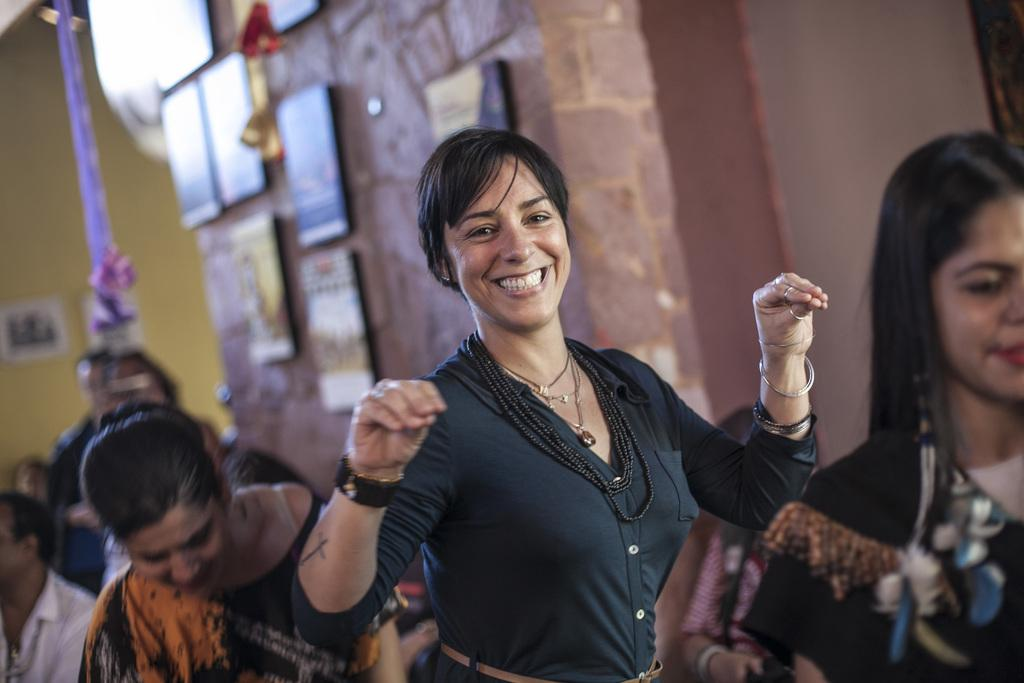What is the woman in the image doing? The woman is standing in the image and smiling. Can you describe the people in the background of the image? There is a group of people standing in the background of the image. What is attached to the wall in the background of the image? There are frames attached to the wall in the background of the image. What type of knot is the woman tying in the image? There is no knot present in the image. What type of planes are flying in the image? There are no planes visible in the image. 